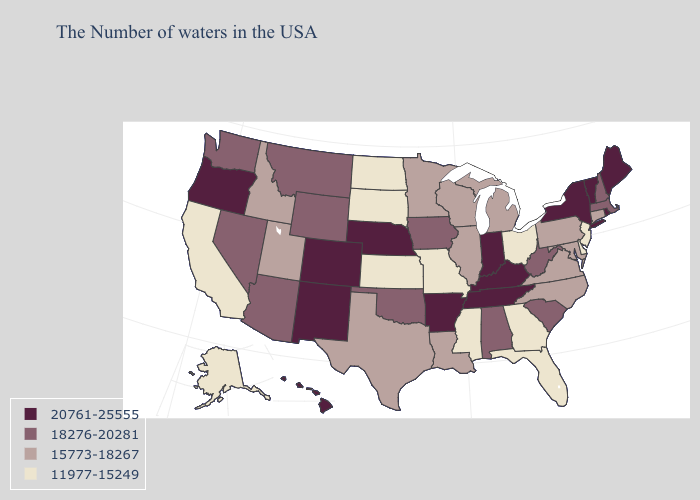What is the highest value in the Northeast ?
Be succinct. 20761-25555. Does the first symbol in the legend represent the smallest category?
Concise answer only. No. Does South Dakota have the same value as Arkansas?
Keep it brief. No. What is the value of Virginia?
Be succinct. 15773-18267. What is the lowest value in the USA?
Keep it brief. 11977-15249. What is the value of Alaska?
Quick response, please. 11977-15249. Which states hav the highest value in the MidWest?
Answer briefly. Indiana, Nebraska. Does Rhode Island have the highest value in the USA?
Short answer required. Yes. Does the map have missing data?
Write a very short answer. No. Among the states that border Indiana , does Ohio have the highest value?
Give a very brief answer. No. Among the states that border Ohio , does Indiana have the highest value?
Concise answer only. Yes. Among the states that border North Dakota , does Minnesota have the lowest value?
Be succinct. No. Name the states that have a value in the range 18276-20281?
Quick response, please. Massachusetts, New Hampshire, South Carolina, West Virginia, Alabama, Iowa, Oklahoma, Wyoming, Montana, Arizona, Nevada, Washington. Does Alaska have the lowest value in the West?
Quick response, please. Yes. 